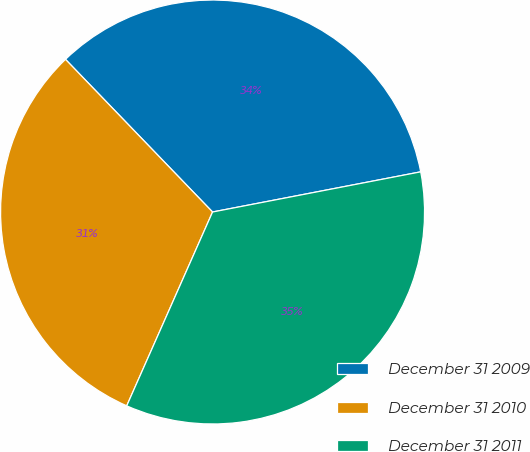Convert chart. <chart><loc_0><loc_0><loc_500><loc_500><pie_chart><fcel>December 31 2009<fcel>December 31 2010<fcel>December 31 2011<nl><fcel>34.17%<fcel>31.16%<fcel>34.67%<nl></chart> 